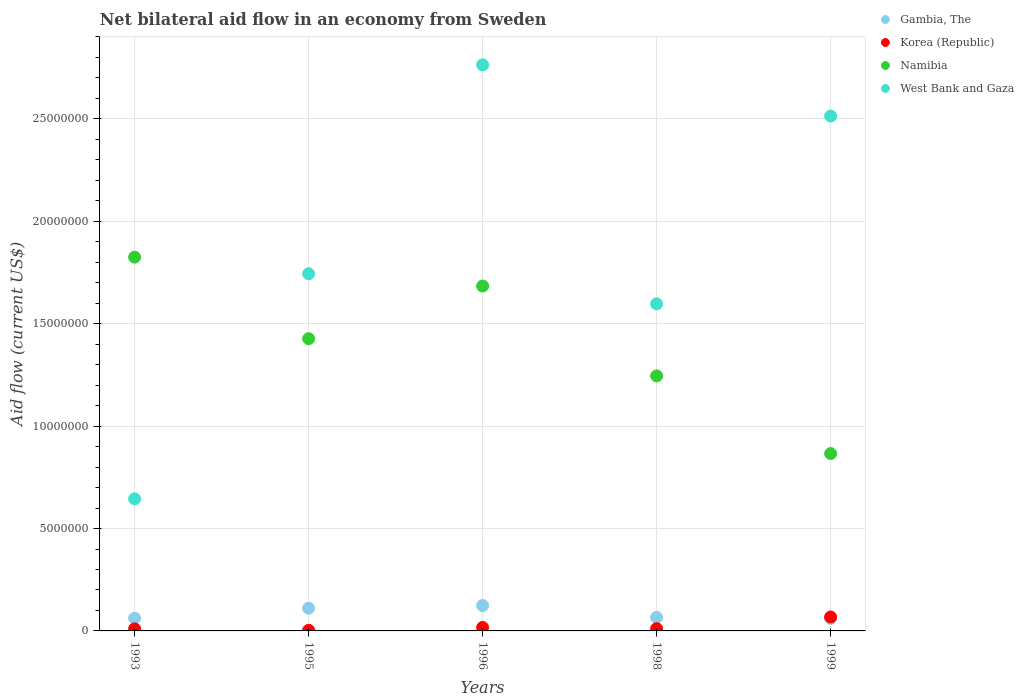What is the net bilateral aid flow in Namibia in 1998?
Offer a terse response. 1.24e+07. Across all years, what is the maximum net bilateral aid flow in West Bank and Gaza?
Give a very brief answer. 2.76e+07. Across all years, what is the minimum net bilateral aid flow in Namibia?
Keep it short and to the point. 8.66e+06. In which year was the net bilateral aid flow in Namibia maximum?
Give a very brief answer. 1993. In which year was the net bilateral aid flow in Korea (Republic) minimum?
Your answer should be very brief. 1995. What is the total net bilateral aid flow in West Bank and Gaza in the graph?
Your answer should be very brief. 9.26e+07. What is the difference between the net bilateral aid flow in Namibia in 1993 and that in 1996?
Keep it short and to the point. 1.41e+06. What is the difference between the net bilateral aid flow in Gambia, The in 1998 and the net bilateral aid flow in West Bank and Gaza in 1999?
Your response must be concise. -2.45e+07. What is the average net bilateral aid flow in West Bank and Gaza per year?
Give a very brief answer. 1.85e+07. In the year 1995, what is the difference between the net bilateral aid flow in West Bank and Gaza and net bilateral aid flow in Korea (Republic)?
Ensure brevity in your answer.  1.74e+07. In how many years, is the net bilateral aid flow in West Bank and Gaza greater than 11000000 US$?
Your response must be concise. 4. What is the ratio of the net bilateral aid flow in Namibia in 1995 to that in 1999?
Offer a very short reply. 1.65. Is the difference between the net bilateral aid flow in West Bank and Gaza in 1998 and 1999 greater than the difference between the net bilateral aid flow in Korea (Republic) in 1998 and 1999?
Your answer should be very brief. No. What is the difference between the highest and the second highest net bilateral aid flow in West Bank and Gaza?
Provide a succinct answer. 2.50e+06. What is the difference between the highest and the lowest net bilateral aid flow in West Bank and Gaza?
Give a very brief answer. 2.12e+07. Is the sum of the net bilateral aid flow in West Bank and Gaza in 1995 and 1998 greater than the maximum net bilateral aid flow in Gambia, The across all years?
Keep it short and to the point. Yes. Is the net bilateral aid flow in West Bank and Gaza strictly greater than the net bilateral aid flow in Gambia, The over the years?
Your response must be concise. Yes. Is the net bilateral aid flow in Korea (Republic) strictly less than the net bilateral aid flow in Namibia over the years?
Give a very brief answer. Yes. How many dotlines are there?
Offer a very short reply. 4. How many years are there in the graph?
Your answer should be very brief. 5. What is the difference between two consecutive major ticks on the Y-axis?
Give a very brief answer. 5.00e+06. Are the values on the major ticks of Y-axis written in scientific E-notation?
Your answer should be very brief. No. Does the graph contain any zero values?
Ensure brevity in your answer.  No. Does the graph contain grids?
Offer a very short reply. Yes. How many legend labels are there?
Your response must be concise. 4. What is the title of the graph?
Provide a succinct answer. Net bilateral aid flow in an economy from Sweden. What is the label or title of the X-axis?
Provide a succinct answer. Years. What is the label or title of the Y-axis?
Ensure brevity in your answer.  Aid flow (current US$). What is the Aid flow (current US$) in Gambia, The in 1993?
Offer a terse response. 6.20e+05. What is the Aid flow (current US$) in Namibia in 1993?
Your response must be concise. 1.82e+07. What is the Aid flow (current US$) of West Bank and Gaza in 1993?
Your answer should be very brief. 6.45e+06. What is the Aid flow (current US$) in Gambia, The in 1995?
Offer a very short reply. 1.11e+06. What is the Aid flow (current US$) of Namibia in 1995?
Keep it short and to the point. 1.43e+07. What is the Aid flow (current US$) of West Bank and Gaza in 1995?
Make the answer very short. 1.74e+07. What is the Aid flow (current US$) in Gambia, The in 1996?
Provide a short and direct response. 1.24e+06. What is the Aid flow (current US$) in Korea (Republic) in 1996?
Ensure brevity in your answer.  1.70e+05. What is the Aid flow (current US$) of Namibia in 1996?
Give a very brief answer. 1.68e+07. What is the Aid flow (current US$) of West Bank and Gaza in 1996?
Keep it short and to the point. 2.76e+07. What is the Aid flow (current US$) in Namibia in 1998?
Provide a succinct answer. 1.24e+07. What is the Aid flow (current US$) in West Bank and Gaza in 1998?
Your response must be concise. 1.60e+07. What is the Aid flow (current US$) in Gambia, The in 1999?
Your answer should be very brief. 6.10e+05. What is the Aid flow (current US$) of Korea (Republic) in 1999?
Give a very brief answer. 6.80e+05. What is the Aid flow (current US$) of Namibia in 1999?
Make the answer very short. 8.66e+06. What is the Aid flow (current US$) of West Bank and Gaza in 1999?
Your response must be concise. 2.51e+07. Across all years, what is the maximum Aid flow (current US$) in Gambia, The?
Offer a terse response. 1.24e+06. Across all years, what is the maximum Aid flow (current US$) in Korea (Republic)?
Keep it short and to the point. 6.80e+05. Across all years, what is the maximum Aid flow (current US$) of Namibia?
Your answer should be very brief. 1.82e+07. Across all years, what is the maximum Aid flow (current US$) in West Bank and Gaza?
Provide a succinct answer. 2.76e+07. Across all years, what is the minimum Aid flow (current US$) of Korea (Republic)?
Make the answer very short. 3.00e+04. Across all years, what is the minimum Aid flow (current US$) in Namibia?
Ensure brevity in your answer.  8.66e+06. Across all years, what is the minimum Aid flow (current US$) in West Bank and Gaza?
Offer a terse response. 6.45e+06. What is the total Aid flow (current US$) in Gambia, The in the graph?
Offer a very short reply. 4.24e+06. What is the total Aid flow (current US$) in Korea (Republic) in the graph?
Keep it short and to the point. 1.09e+06. What is the total Aid flow (current US$) in Namibia in the graph?
Ensure brevity in your answer.  7.05e+07. What is the total Aid flow (current US$) of West Bank and Gaza in the graph?
Give a very brief answer. 9.26e+07. What is the difference between the Aid flow (current US$) of Gambia, The in 1993 and that in 1995?
Ensure brevity in your answer.  -4.90e+05. What is the difference between the Aid flow (current US$) in Namibia in 1993 and that in 1995?
Provide a succinct answer. 3.98e+06. What is the difference between the Aid flow (current US$) of West Bank and Gaza in 1993 and that in 1995?
Offer a very short reply. -1.10e+07. What is the difference between the Aid flow (current US$) of Gambia, The in 1993 and that in 1996?
Your answer should be very brief. -6.20e+05. What is the difference between the Aid flow (current US$) of Korea (Republic) in 1993 and that in 1996?
Your answer should be compact. -7.00e+04. What is the difference between the Aid flow (current US$) of Namibia in 1993 and that in 1996?
Make the answer very short. 1.41e+06. What is the difference between the Aid flow (current US$) of West Bank and Gaza in 1993 and that in 1996?
Offer a very short reply. -2.12e+07. What is the difference between the Aid flow (current US$) of Namibia in 1993 and that in 1998?
Provide a short and direct response. 5.80e+06. What is the difference between the Aid flow (current US$) of West Bank and Gaza in 1993 and that in 1998?
Make the answer very short. -9.52e+06. What is the difference between the Aid flow (current US$) of Korea (Republic) in 1993 and that in 1999?
Keep it short and to the point. -5.80e+05. What is the difference between the Aid flow (current US$) in Namibia in 1993 and that in 1999?
Offer a very short reply. 9.59e+06. What is the difference between the Aid flow (current US$) in West Bank and Gaza in 1993 and that in 1999?
Your answer should be very brief. -1.87e+07. What is the difference between the Aid flow (current US$) of Gambia, The in 1995 and that in 1996?
Provide a succinct answer. -1.30e+05. What is the difference between the Aid flow (current US$) of Namibia in 1995 and that in 1996?
Provide a succinct answer. -2.57e+06. What is the difference between the Aid flow (current US$) in West Bank and Gaza in 1995 and that in 1996?
Keep it short and to the point. -1.02e+07. What is the difference between the Aid flow (current US$) of Gambia, The in 1995 and that in 1998?
Keep it short and to the point. 4.50e+05. What is the difference between the Aid flow (current US$) in Namibia in 1995 and that in 1998?
Your answer should be very brief. 1.82e+06. What is the difference between the Aid flow (current US$) of West Bank and Gaza in 1995 and that in 1998?
Your answer should be compact. 1.47e+06. What is the difference between the Aid flow (current US$) in Gambia, The in 1995 and that in 1999?
Offer a terse response. 5.00e+05. What is the difference between the Aid flow (current US$) of Korea (Republic) in 1995 and that in 1999?
Your answer should be very brief. -6.50e+05. What is the difference between the Aid flow (current US$) in Namibia in 1995 and that in 1999?
Your answer should be compact. 5.61e+06. What is the difference between the Aid flow (current US$) of West Bank and Gaza in 1995 and that in 1999?
Make the answer very short. -7.70e+06. What is the difference between the Aid flow (current US$) in Gambia, The in 1996 and that in 1998?
Offer a terse response. 5.80e+05. What is the difference between the Aid flow (current US$) of Namibia in 1996 and that in 1998?
Your response must be concise. 4.39e+06. What is the difference between the Aid flow (current US$) in West Bank and Gaza in 1996 and that in 1998?
Offer a very short reply. 1.17e+07. What is the difference between the Aid flow (current US$) in Gambia, The in 1996 and that in 1999?
Offer a very short reply. 6.30e+05. What is the difference between the Aid flow (current US$) of Korea (Republic) in 1996 and that in 1999?
Your answer should be very brief. -5.10e+05. What is the difference between the Aid flow (current US$) in Namibia in 1996 and that in 1999?
Make the answer very short. 8.18e+06. What is the difference between the Aid flow (current US$) of West Bank and Gaza in 1996 and that in 1999?
Give a very brief answer. 2.50e+06. What is the difference between the Aid flow (current US$) of Korea (Republic) in 1998 and that in 1999?
Your response must be concise. -5.70e+05. What is the difference between the Aid flow (current US$) of Namibia in 1998 and that in 1999?
Your answer should be very brief. 3.79e+06. What is the difference between the Aid flow (current US$) of West Bank and Gaza in 1998 and that in 1999?
Make the answer very short. -9.17e+06. What is the difference between the Aid flow (current US$) in Gambia, The in 1993 and the Aid flow (current US$) in Korea (Republic) in 1995?
Make the answer very short. 5.90e+05. What is the difference between the Aid flow (current US$) of Gambia, The in 1993 and the Aid flow (current US$) of Namibia in 1995?
Offer a very short reply. -1.36e+07. What is the difference between the Aid flow (current US$) of Gambia, The in 1993 and the Aid flow (current US$) of West Bank and Gaza in 1995?
Provide a short and direct response. -1.68e+07. What is the difference between the Aid flow (current US$) in Korea (Republic) in 1993 and the Aid flow (current US$) in Namibia in 1995?
Your answer should be compact. -1.42e+07. What is the difference between the Aid flow (current US$) in Korea (Republic) in 1993 and the Aid flow (current US$) in West Bank and Gaza in 1995?
Your answer should be compact. -1.73e+07. What is the difference between the Aid flow (current US$) in Namibia in 1993 and the Aid flow (current US$) in West Bank and Gaza in 1995?
Provide a short and direct response. 8.10e+05. What is the difference between the Aid flow (current US$) in Gambia, The in 1993 and the Aid flow (current US$) in Korea (Republic) in 1996?
Provide a succinct answer. 4.50e+05. What is the difference between the Aid flow (current US$) of Gambia, The in 1993 and the Aid flow (current US$) of Namibia in 1996?
Offer a terse response. -1.62e+07. What is the difference between the Aid flow (current US$) of Gambia, The in 1993 and the Aid flow (current US$) of West Bank and Gaza in 1996?
Offer a very short reply. -2.70e+07. What is the difference between the Aid flow (current US$) of Korea (Republic) in 1993 and the Aid flow (current US$) of Namibia in 1996?
Provide a short and direct response. -1.67e+07. What is the difference between the Aid flow (current US$) in Korea (Republic) in 1993 and the Aid flow (current US$) in West Bank and Gaza in 1996?
Provide a short and direct response. -2.75e+07. What is the difference between the Aid flow (current US$) of Namibia in 1993 and the Aid flow (current US$) of West Bank and Gaza in 1996?
Your answer should be very brief. -9.39e+06. What is the difference between the Aid flow (current US$) in Gambia, The in 1993 and the Aid flow (current US$) in Korea (Republic) in 1998?
Make the answer very short. 5.10e+05. What is the difference between the Aid flow (current US$) in Gambia, The in 1993 and the Aid flow (current US$) in Namibia in 1998?
Keep it short and to the point. -1.18e+07. What is the difference between the Aid flow (current US$) in Gambia, The in 1993 and the Aid flow (current US$) in West Bank and Gaza in 1998?
Ensure brevity in your answer.  -1.54e+07. What is the difference between the Aid flow (current US$) of Korea (Republic) in 1993 and the Aid flow (current US$) of Namibia in 1998?
Ensure brevity in your answer.  -1.24e+07. What is the difference between the Aid flow (current US$) in Korea (Republic) in 1993 and the Aid flow (current US$) in West Bank and Gaza in 1998?
Ensure brevity in your answer.  -1.59e+07. What is the difference between the Aid flow (current US$) of Namibia in 1993 and the Aid flow (current US$) of West Bank and Gaza in 1998?
Your answer should be very brief. 2.28e+06. What is the difference between the Aid flow (current US$) of Gambia, The in 1993 and the Aid flow (current US$) of Namibia in 1999?
Provide a short and direct response. -8.04e+06. What is the difference between the Aid flow (current US$) in Gambia, The in 1993 and the Aid flow (current US$) in West Bank and Gaza in 1999?
Your answer should be compact. -2.45e+07. What is the difference between the Aid flow (current US$) in Korea (Republic) in 1993 and the Aid flow (current US$) in Namibia in 1999?
Give a very brief answer. -8.56e+06. What is the difference between the Aid flow (current US$) in Korea (Republic) in 1993 and the Aid flow (current US$) in West Bank and Gaza in 1999?
Your answer should be very brief. -2.50e+07. What is the difference between the Aid flow (current US$) of Namibia in 1993 and the Aid flow (current US$) of West Bank and Gaza in 1999?
Make the answer very short. -6.89e+06. What is the difference between the Aid flow (current US$) in Gambia, The in 1995 and the Aid flow (current US$) in Korea (Republic) in 1996?
Make the answer very short. 9.40e+05. What is the difference between the Aid flow (current US$) in Gambia, The in 1995 and the Aid flow (current US$) in Namibia in 1996?
Offer a terse response. -1.57e+07. What is the difference between the Aid flow (current US$) in Gambia, The in 1995 and the Aid flow (current US$) in West Bank and Gaza in 1996?
Your answer should be very brief. -2.65e+07. What is the difference between the Aid flow (current US$) of Korea (Republic) in 1995 and the Aid flow (current US$) of Namibia in 1996?
Offer a very short reply. -1.68e+07. What is the difference between the Aid flow (current US$) in Korea (Republic) in 1995 and the Aid flow (current US$) in West Bank and Gaza in 1996?
Ensure brevity in your answer.  -2.76e+07. What is the difference between the Aid flow (current US$) of Namibia in 1995 and the Aid flow (current US$) of West Bank and Gaza in 1996?
Offer a terse response. -1.34e+07. What is the difference between the Aid flow (current US$) in Gambia, The in 1995 and the Aid flow (current US$) in Korea (Republic) in 1998?
Make the answer very short. 1.00e+06. What is the difference between the Aid flow (current US$) of Gambia, The in 1995 and the Aid flow (current US$) of Namibia in 1998?
Offer a terse response. -1.13e+07. What is the difference between the Aid flow (current US$) of Gambia, The in 1995 and the Aid flow (current US$) of West Bank and Gaza in 1998?
Keep it short and to the point. -1.49e+07. What is the difference between the Aid flow (current US$) in Korea (Republic) in 1995 and the Aid flow (current US$) in Namibia in 1998?
Offer a terse response. -1.24e+07. What is the difference between the Aid flow (current US$) of Korea (Republic) in 1995 and the Aid flow (current US$) of West Bank and Gaza in 1998?
Provide a short and direct response. -1.59e+07. What is the difference between the Aid flow (current US$) in Namibia in 1995 and the Aid flow (current US$) in West Bank and Gaza in 1998?
Your answer should be very brief. -1.70e+06. What is the difference between the Aid flow (current US$) in Gambia, The in 1995 and the Aid flow (current US$) in Korea (Republic) in 1999?
Give a very brief answer. 4.30e+05. What is the difference between the Aid flow (current US$) of Gambia, The in 1995 and the Aid flow (current US$) of Namibia in 1999?
Give a very brief answer. -7.55e+06. What is the difference between the Aid flow (current US$) in Gambia, The in 1995 and the Aid flow (current US$) in West Bank and Gaza in 1999?
Ensure brevity in your answer.  -2.40e+07. What is the difference between the Aid flow (current US$) in Korea (Republic) in 1995 and the Aid flow (current US$) in Namibia in 1999?
Your answer should be compact. -8.63e+06. What is the difference between the Aid flow (current US$) in Korea (Republic) in 1995 and the Aid flow (current US$) in West Bank and Gaza in 1999?
Your response must be concise. -2.51e+07. What is the difference between the Aid flow (current US$) of Namibia in 1995 and the Aid flow (current US$) of West Bank and Gaza in 1999?
Offer a very short reply. -1.09e+07. What is the difference between the Aid flow (current US$) of Gambia, The in 1996 and the Aid flow (current US$) of Korea (Republic) in 1998?
Provide a short and direct response. 1.13e+06. What is the difference between the Aid flow (current US$) of Gambia, The in 1996 and the Aid flow (current US$) of Namibia in 1998?
Ensure brevity in your answer.  -1.12e+07. What is the difference between the Aid flow (current US$) in Gambia, The in 1996 and the Aid flow (current US$) in West Bank and Gaza in 1998?
Ensure brevity in your answer.  -1.47e+07. What is the difference between the Aid flow (current US$) of Korea (Republic) in 1996 and the Aid flow (current US$) of Namibia in 1998?
Your answer should be compact. -1.23e+07. What is the difference between the Aid flow (current US$) in Korea (Republic) in 1996 and the Aid flow (current US$) in West Bank and Gaza in 1998?
Offer a very short reply. -1.58e+07. What is the difference between the Aid flow (current US$) in Namibia in 1996 and the Aid flow (current US$) in West Bank and Gaza in 1998?
Offer a terse response. 8.70e+05. What is the difference between the Aid flow (current US$) of Gambia, The in 1996 and the Aid flow (current US$) of Korea (Republic) in 1999?
Make the answer very short. 5.60e+05. What is the difference between the Aid flow (current US$) in Gambia, The in 1996 and the Aid flow (current US$) in Namibia in 1999?
Offer a very short reply. -7.42e+06. What is the difference between the Aid flow (current US$) of Gambia, The in 1996 and the Aid flow (current US$) of West Bank and Gaza in 1999?
Ensure brevity in your answer.  -2.39e+07. What is the difference between the Aid flow (current US$) in Korea (Republic) in 1996 and the Aid flow (current US$) in Namibia in 1999?
Provide a succinct answer. -8.49e+06. What is the difference between the Aid flow (current US$) in Korea (Republic) in 1996 and the Aid flow (current US$) in West Bank and Gaza in 1999?
Offer a very short reply. -2.50e+07. What is the difference between the Aid flow (current US$) in Namibia in 1996 and the Aid flow (current US$) in West Bank and Gaza in 1999?
Offer a terse response. -8.30e+06. What is the difference between the Aid flow (current US$) in Gambia, The in 1998 and the Aid flow (current US$) in Korea (Republic) in 1999?
Your response must be concise. -2.00e+04. What is the difference between the Aid flow (current US$) of Gambia, The in 1998 and the Aid flow (current US$) of Namibia in 1999?
Offer a terse response. -8.00e+06. What is the difference between the Aid flow (current US$) in Gambia, The in 1998 and the Aid flow (current US$) in West Bank and Gaza in 1999?
Offer a terse response. -2.45e+07. What is the difference between the Aid flow (current US$) of Korea (Republic) in 1998 and the Aid flow (current US$) of Namibia in 1999?
Make the answer very short. -8.55e+06. What is the difference between the Aid flow (current US$) in Korea (Republic) in 1998 and the Aid flow (current US$) in West Bank and Gaza in 1999?
Your answer should be compact. -2.50e+07. What is the difference between the Aid flow (current US$) in Namibia in 1998 and the Aid flow (current US$) in West Bank and Gaza in 1999?
Your answer should be compact. -1.27e+07. What is the average Aid flow (current US$) of Gambia, The per year?
Make the answer very short. 8.48e+05. What is the average Aid flow (current US$) in Korea (Republic) per year?
Ensure brevity in your answer.  2.18e+05. What is the average Aid flow (current US$) in Namibia per year?
Make the answer very short. 1.41e+07. What is the average Aid flow (current US$) in West Bank and Gaza per year?
Your response must be concise. 1.85e+07. In the year 1993, what is the difference between the Aid flow (current US$) in Gambia, The and Aid flow (current US$) in Korea (Republic)?
Make the answer very short. 5.20e+05. In the year 1993, what is the difference between the Aid flow (current US$) in Gambia, The and Aid flow (current US$) in Namibia?
Give a very brief answer. -1.76e+07. In the year 1993, what is the difference between the Aid flow (current US$) of Gambia, The and Aid flow (current US$) of West Bank and Gaza?
Offer a terse response. -5.83e+06. In the year 1993, what is the difference between the Aid flow (current US$) of Korea (Republic) and Aid flow (current US$) of Namibia?
Offer a terse response. -1.82e+07. In the year 1993, what is the difference between the Aid flow (current US$) of Korea (Republic) and Aid flow (current US$) of West Bank and Gaza?
Your answer should be very brief. -6.35e+06. In the year 1993, what is the difference between the Aid flow (current US$) of Namibia and Aid flow (current US$) of West Bank and Gaza?
Provide a short and direct response. 1.18e+07. In the year 1995, what is the difference between the Aid flow (current US$) of Gambia, The and Aid flow (current US$) of Korea (Republic)?
Provide a short and direct response. 1.08e+06. In the year 1995, what is the difference between the Aid flow (current US$) in Gambia, The and Aid flow (current US$) in Namibia?
Provide a short and direct response. -1.32e+07. In the year 1995, what is the difference between the Aid flow (current US$) in Gambia, The and Aid flow (current US$) in West Bank and Gaza?
Your response must be concise. -1.63e+07. In the year 1995, what is the difference between the Aid flow (current US$) of Korea (Republic) and Aid flow (current US$) of Namibia?
Offer a terse response. -1.42e+07. In the year 1995, what is the difference between the Aid flow (current US$) of Korea (Republic) and Aid flow (current US$) of West Bank and Gaza?
Give a very brief answer. -1.74e+07. In the year 1995, what is the difference between the Aid flow (current US$) in Namibia and Aid flow (current US$) in West Bank and Gaza?
Your response must be concise. -3.17e+06. In the year 1996, what is the difference between the Aid flow (current US$) of Gambia, The and Aid flow (current US$) of Korea (Republic)?
Give a very brief answer. 1.07e+06. In the year 1996, what is the difference between the Aid flow (current US$) in Gambia, The and Aid flow (current US$) in Namibia?
Provide a succinct answer. -1.56e+07. In the year 1996, what is the difference between the Aid flow (current US$) in Gambia, The and Aid flow (current US$) in West Bank and Gaza?
Your response must be concise. -2.64e+07. In the year 1996, what is the difference between the Aid flow (current US$) in Korea (Republic) and Aid flow (current US$) in Namibia?
Make the answer very short. -1.67e+07. In the year 1996, what is the difference between the Aid flow (current US$) in Korea (Republic) and Aid flow (current US$) in West Bank and Gaza?
Your answer should be compact. -2.75e+07. In the year 1996, what is the difference between the Aid flow (current US$) of Namibia and Aid flow (current US$) of West Bank and Gaza?
Provide a short and direct response. -1.08e+07. In the year 1998, what is the difference between the Aid flow (current US$) of Gambia, The and Aid flow (current US$) of Namibia?
Your answer should be very brief. -1.18e+07. In the year 1998, what is the difference between the Aid flow (current US$) in Gambia, The and Aid flow (current US$) in West Bank and Gaza?
Provide a succinct answer. -1.53e+07. In the year 1998, what is the difference between the Aid flow (current US$) in Korea (Republic) and Aid flow (current US$) in Namibia?
Your answer should be very brief. -1.23e+07. In the year 1998, what is the difference between the Aid flow (current US$) of Korea (Republic) and Aid flow (current US$) of West Bank and Gaza?
Offer a very short reply. -1.59e+07. In the year 1998, what is the difference between the Aid flow (current US$) in Namibia and Aid flow (current US$) in West Bank and Gaza?
Keep it short and to the point. -3.52e+06. In the year 1999, what is the difference between the Aid flow (current US$) of Gambia, The and Aid flow (current US$) of Namibia?
Offer a terse response. -8.05e+06. In the year 1999, what is the difference between the Aid flow (current US$) in Gambia, The and Aid flow (current US$) in West Bank and Gaza?
Your answer should be very brief. -2.45e+07. In the year 1999, what is the difference between the Aid flow (current US$) in Korea (Republic) and Aid flow (current US$) in Namibia?
Ensure brevity in your answer.  -7.98e+06. In the year 1999, what is the difference between the Aid flow (current US$) of Korea (Republic) and Aid flow (current US$) of West Bank and Gaza?
Make the answer very short. -2.45e+07. In the year 1999, what is the difference between the Aid flow (current US$) in Namibia and Aid flow (current US$) in West Bank and Gaza?
Your answer should be very brief. -1.65e+07. What is the ratio of the Aid flow (current US$) of Gambia, The in 1993 to that in 1995?
Your answer should be compact. 0.56. What is the ratio of the Aid flow (current US$) of Namibia in 1993 to that in 1995?
Your response must be concise. 1.28. What is the ratio of the Aid flow (current US$) in West Bank and Gaza in 1993 to that in 1995?
Offer a terse response. 0.37. What is the ratio of the Aid flow (current US$) of Korea (Republic) in 1993 to that in 1996?
Your answer should be very brief. 0.59. What is the ratio of the Aid flow (current US$) of Namibia in 1993 to that in 1996?
Offer a terse response. 1.08. What is the ratio of the Aid flow (current US$) of West Bank and Gaza in 1993 to that in 1996?
Your answer should be compact. 0.23. What is the ratio of the Aid flow (current US$) in Gambia, The in 1993 to that in 1998?
Ensure brevity in your answer.  0.94. What is the ratio of the Aid flow (current US$) in Korea (Republic) in 1993 to that in 1998?
Your response must be concise. 0.91. What is the ratio of the Aid flow (current US$) in Namibia in 1993 to that in 1998?
Offer a terse response. 1.47. What is the ratio of the Aid flow (current US$) in West Bank and Gaza in 1993 to that in 1998?
Provide a succinct answer. 0.4. What is the ratio of the Aid flow (current US$) of Gambia, The in 1993 to that in 1999?
Your answer should be compact. 1.02. What is the ratio of the Aid flow (current US$) of Korea (Republic) in 1993 to that in 1999?
Provide a succinct answer. 0.15. What is the ratio of the Aid flow (current US$) of Namibia in 1993 to that in 1999?
Make the answer very short. 2.11. What is the ratio of the Aid flow (current US$) of West Bank and Gaza in 1993 to that in 1999?
Offer a very short reply. 0.26. What is the ratio of the Aid flow (current US$) in Gambia, The in 1995 to that in 1996?
Ensure brevity in your answer.  0.9. What is the ratio of the Aid flow (current US$) in Korea (Republic) in 1995 to that in 1996?
Your answer should be compact. 0.18. What is the ratio of the Aid flow (current US$) in Namibia in 1995 to that in 1996?
Offer a terse response. 0.85. What is the ratio of the Aid flow (current US$) in West Bank and Gaza in 1995 to that in 1996?
Keep it short and to the point. 0.63. What is the ratio of the Aid flow (current US$) in Gambia, The in 1995 to that in 1998?
Offer a very short reply. 1.68. What is the ratio of the Aid flow (current US$) in Korea (Republic) in 1995 to that in 1998?
Your response must be concise. 0.27. What is the ratio of the Aid flow (current US$) in Namibia in 1995 to that in 1998?
Make the answer very short. 1.15. What is the ratio of the Aid flow (current US$) of West Bank and Gaza in 1995 to that in 1998?
Make the answer very short. 1.09. What is the ratio of the Aid flow (current US$) in Gambia, The in 1995 to that in 1999?
Provide a succinct answer. 1.82. What is the ratio of the Aid flow (current US$) in Korea (Republic) in 1995 to that in 1999?
Your response must be concise. 0.04. What is the ratio of the Aid flow (current US$) of Namibia in 1995 to that in 1999?
Make the answer very short. 1.65. What is the ratio of the Aid flow (current US$) of West Bank and Gaza in 1995 to that in 1999?
Make the answer very short. 0.69. What is the ratio of the Aid flow (current US$) in Gambia, The in 1996 to that in 1998?
Make the answer very short. 1.88. What is the ratio of the Aid flow (current US$) in Korea (Republic) in 1996 to that in 1998?
Offer a very short reply. 1.55. What is the ratio of the Aid flow (current US$) of Namibia in 1996 to that in 1998?
Your answer should be very brief. 1.35. What is the ratio of the Aid flow (current US$) of West Bank and Gaza in 1996 to that in 1998?
Offer a very short reply. 1.73. What is the ratio of the Aid flow (current US$) in Gambia, The in 1996 to that in 1999?
Offer a terse response. 2.03. What is the ratio of the Aid flow (current US$) of Namibia in 1996 to that in 1999?
Offer a terse response. 1.94. What is the ratio of the Aid flow (current US$) in West Bank and Gaza in 1996 to that in 1999?
Ensure brevity in your answer.  1.1. What is the ratio of the Aid flow (current US$) of Gambia, The in 1998 to that in 1999?
Ensure brevity in your answer.  1.08. What is the ratio of the Aid flow (current US$) in Korea (Republic) in 1998 to that in 1999?
Offer a terse response. 0.16. What is the ratio of the Aid flow (current US$) of Namibia in 1998 to that in 1999?
Give a very brief answer. 1.44. What is the ratio of the Aid flow (current US$) of West Bank and Gaza in 1998 to that in 1999?
Your answer should be very brief. 0.64. What is the difference between the highest and the second highest Aid flow (current US$) in Korea (Republic)?
Make the answer very short. 5.10e+05. What is the difference between the highest and the second highest Aid flow (current US$) in Namibia?
Provide a short and direct response. 1.41e+06. What is the difference between the highest and the second highest Aid flow (current US$) in West Bank and Gaza?
Your answer should be compact. 2.50e+06. What is the difference between the highest and the lowest Aid flow (current US$) of Gambia, The?
Provide a succinct answer. 6.30e+05. What is the difference between the highest and the lowest Aid flow (current US$) of Korea (Republic)?
Offer a very short reply. 6.50e+05. What is the difference between the highest and the lowest Aid flow (current US$) in Namibia?
Offer a terse response. 9.59e+06. What is the difference between the highest and the lowest Aid flow (current US$) of West Bank and Gaza?
Give a very brief answer. 2.12e+07. 